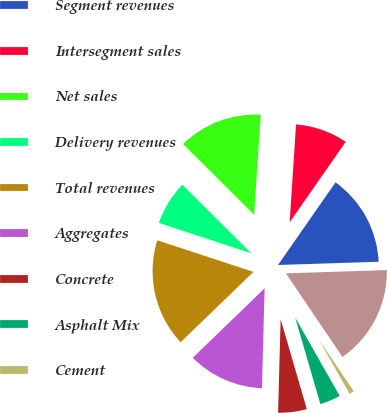Convert chart. <chart><loc_0><loc_0><loc_500><loc_500><pie_chart><fcel>in millions<fcel>Segment revenues<fcel>Intersegment sales<fcel>Net sales<fcel>Delivery revenues<fcel>Total revenues<fcel>Aggregates<fcel>Concrete<fcel>Asphalt Mix<fcel>Cement<nl><fcel>16.05%<fcel>14.81%<fcel>8.64%<fcel>13.58%<fcel>7.41%<fcel>17.28%<fcel>12.34%<fcel>4.94%<fcel>3.71%<fcel>1.24%<nl></chart> 